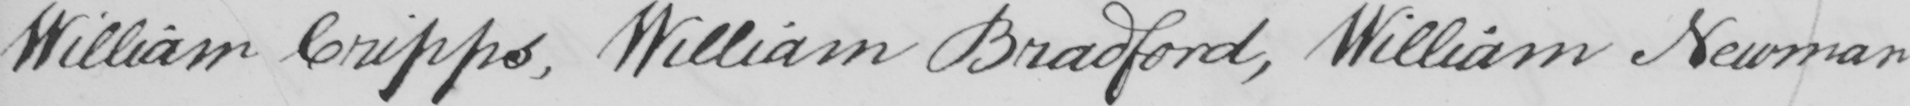Please provide the text content of this handwritten line. William Cripps , William Bradford , William Newman 